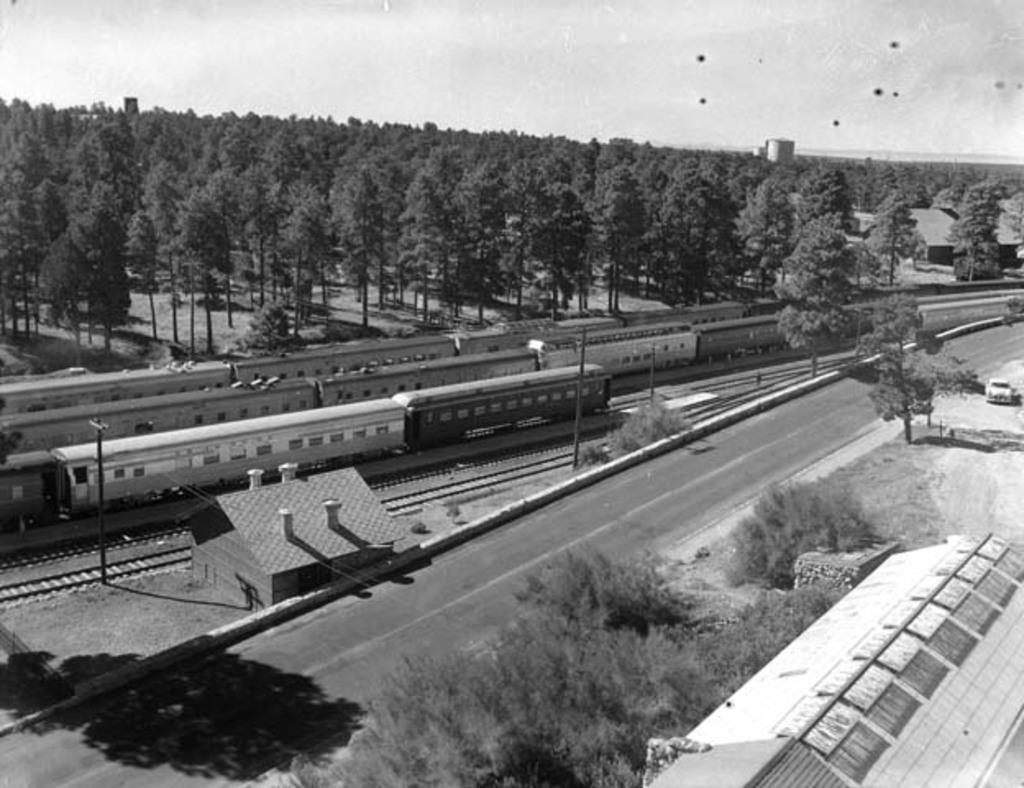Describe this image in one or two sentences. In this image in the front there are plants and in the background there are trains running on the platform and there are trees and there is tent. On the right side there is a car which is white in colour is visible. 